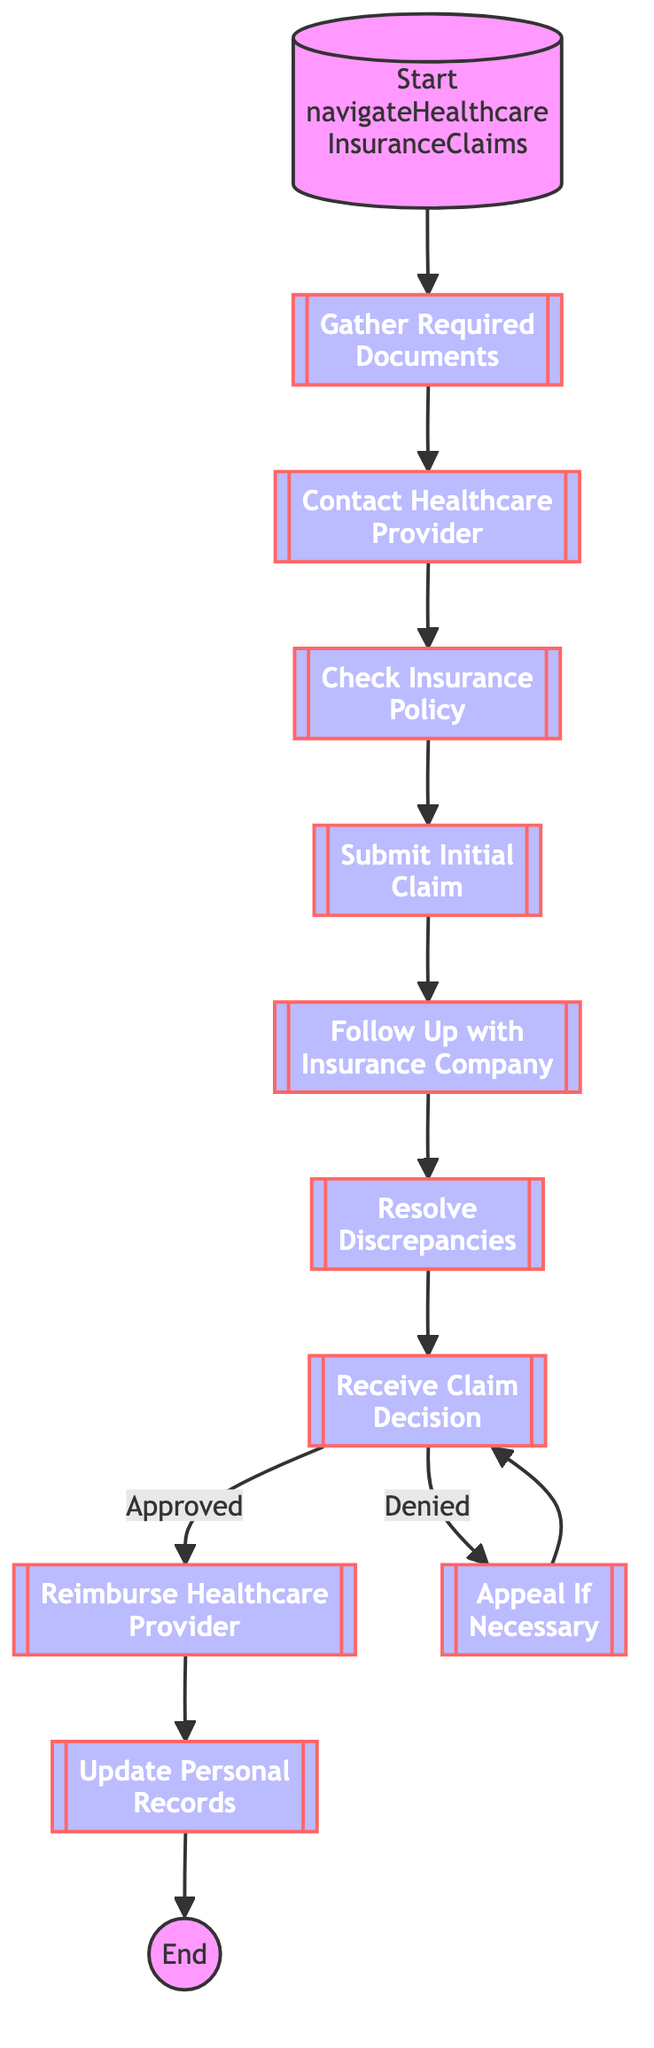What is the first step in the process? The first step is labeled "Gather Required Documents," which is indicated as the initial action in the flowchart.
Answer: Gather Required Documents How many total steps are there? The diagram includes ten distinct steps, starting from gathering documents to updating personal records.
Answer: 10 What happens if the claim is denied? If the claim is denied, the diagram indicates to "Appeal If Necessary," which signifies the action to take following denial.
Answer: Appeal If Necessary What step follows after receiving the claim decision? After receiving the claim decision, if approved, the next step is to "Reimburse Healthcare Provider," as shown by the flow from the claim decision to reimbursement.
Answer: Reimburse Healthcare Provider What is the final action in the process? The final action indicated in the flowchart is "Update Personal Records," which concludes the process after reimbursement.
Answer: Update Personal Records What must be done after submitting the initial claim? After submitting the initial claim, the next task is to "Follow Up with Insurance Company," confirming the status of the claim submission.
Answer: Follow Up with Insurance Company What two outcomes can result from receiving a claim decision? The flowchart specifies two possible outcomes: "Approved" or "Denied," indicating the result of the claim processing.
Answer: Approved and Denied What document types are required in the first step? The first step mentions collecting "medical records, insurance cards, and proof of overseas employment" as necessary documents.
Answer: Medical records, insurance cards, and proof of overseas employment What action should be taken after resolving discrepancies? After resolving discrepancies, the process continues to "Receive Claim Decision," as shown by the next step in the flow.
Answer: Receive Claim Decision 